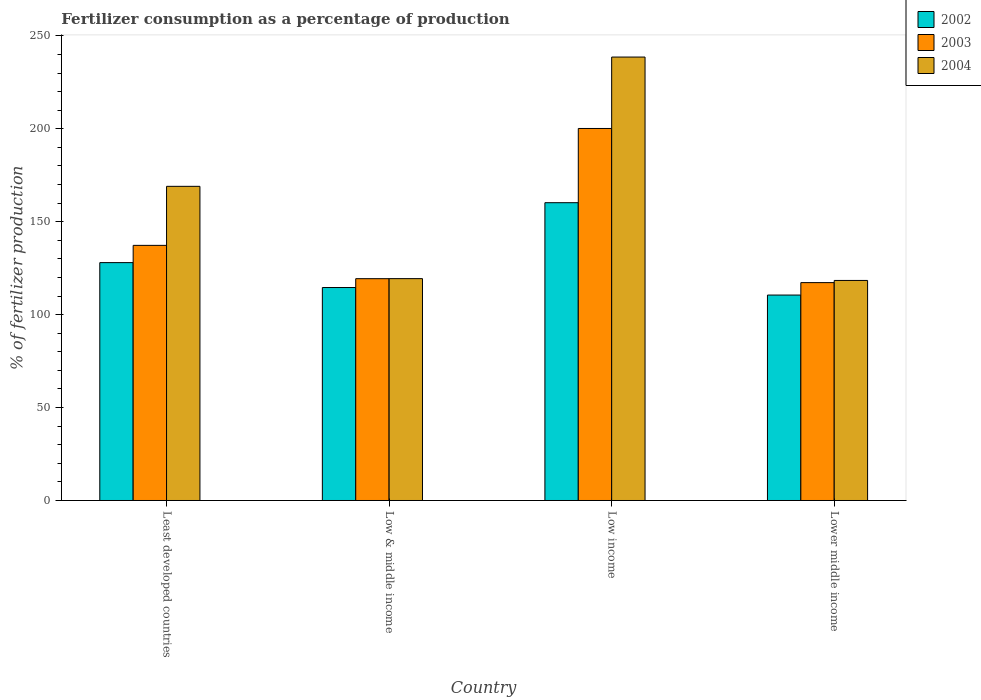How many groups of bars are there?
Provide a succinct answer. 4. How many bars are there on the 4th tick from the left?
Ensure brevity in your answer.  3. How many bars are there on the 1st tick from the right?
Give a very brief answer. 3. What is the label of the 4th group of bars from the left?
Provide a short and direct response. Lower middle income. What is the percentage of fertilizers consumed in 2002 in Least developed countries?
Your response must be concise. 128. Across all countries, what is the maximum percentage of fertilizers consumed in 2003?
Make the answer very short. 200.18. Across all countries, what is the minimum percentage of fertilizers consumed in 2002?
Offer a very short reply. 110.54. In which country was the percentage of fertilizers consumed in 2002 maximum?
Give a very brief answer. Low income. In which country was the percentage of fertilizers consumed in 2004 minimum?
Keep it short and to the point. Lower middle income. What is the total percentage of fertilizers consumed in 2004 in the graph?
Offer a very short reply. 645.43. What is the difference between the percentage of fertilizers consumed in 2003 in Low & middle income and that in Lower middle income?
Make the answer very short. 2.13. What is the difference between the percentage of fertilizers consumed in 2002 in Low income and the percentage of fertilizers consumed in 2004 in Lower middle income?
Ensure brevity in your answer.  41.84. What is the average percentage of fertilizers consumed in 2003 per country?
Make the answer very short. 143.51. What is the difference between the percentage of fertilizers consumed of/in 2004 and percentage of fertilizers consumed of/in 2002 in Low income?
Ensure brevity in your answer.  78.37. In how many countries, is the percentage of fertilizers consumed in 2002 greater than 30 %?
Make the answer very short. 4. What is the ratio of the percentage of fertilizers consumed in 2004 in Low & middle income to that in Low income?
Your response must be concise. 0.5. Is the difference between the percentage of fertilizers consumed in 2004 in Least developed countries and Low income greater than the difference between the percentage of fertilizers consumed in 2002 in Least developed countries and Low income?
Provide a succinct answer. No. What is the difference between the highest and the second highest percentage of fertilizers consumed in 2004?
Your response must be concise. -69.57. What is the difference between the highest and the lowest percentage of fertilizers consumed in 2004?
Your answer should be very brief. 120.21. What does the 2nd bar from the right in Lower middle income represents?
Keep it short and to the point. 2003. Is it the case that in every country, the sum of the percentage of fertilizers consumed in 2003 and percentage of fertilizers consumed in 2004 is greater than the percentage of fertilizers consumed in 2002?
Keep it short and to the point. Yes. Are all the bars in the graph horizontal?
Offer a terse response. No. How many countries are there in the graph?
Make the answer very short. 4. What is the difference between two consecutive major ticks on the Y-axis?
Make the answer very short. 50. Are the values on the major ticks of Y-axis written in scientific E-notation?
Keep it short and to the point. No. Does the graph contain any zero values?
Provide a short and direct response. No. Does the graph contain grids?
Give a very brief answer. No. Where does the legend appear in the graph?
Provide a succinct answer. Top right. What is the title of the graph?
Provide a succinct answer. Fertilizer consumption as a percentage of production. Does "1992" appear as one of the legend labels in the graph?
Your answer should be compact. No. What is the label or title of the X-axis?
Offer a very short reply. Country. What is the label or title of the Y-axis?
Offer a very short reply. % of fertilizer production. What is the % of fertilizer production of 2002 in Least developed countries?
Ensure brevity in your answer.  128. What is the % of fertilizer production in 2003 in Least developed countries?
Offer a terse response. 137.28. What is the % of fertilizer production of 2004 in Least developed countries?
Provide a short and direct response. 169.04. What is the % of fertilizer production of 2002 in Low & middle income?
Your answer should be compact. 114.59. What is the % of fertilizer production in 2003 in Low & middle income?
Make the answer very short. 119.36. What is the % of fertilizer production of 2004 in Low & middle income?
Your response must be concise. 119.38. What is the % of fertilizer production of 2002 in Low income?
Keep it short and to the point. 160.24. What is the % of fertilizer production of 2003 in Low income?
Your answer should be very brief. 200.18. What is the % of fertilizer production in 2004 in Low income?
Provide a succinct answer. 238.61. What is the % of fertilizer production in 2002 in Lower middle income?
Provide a succinct answer. 110.54. What is the % of fertilizer production in 2003 in Lower middle income?
Your response must be concise. 117.23. What is the % of fertilizer production of 2004 in Lower middle income?
Your answer should be very brief. 118.4. Across all countries, what is the maximum % of fertilizer production in 2002?
Your response must be concise. 160.24. Across all countries, what is the maximum % of fertilizer production of 2003?
Offer a terse response. 200.18. Across all countries, what is the maximum % of fertilizer production of 2004?
Give a very brief answer. 238.61. Across all countries, what is the minimum % of fertilizer production in 2002?
Provide a succinct answer. 110.54. Across all countries, what is the minimum % of fertilizer production of 2003?
Offer a very short reply. 117.23. Across all countries, what is the minimum % of fertilizer production of 2004?
Ensure brevity in your answer.  118.4. What is the total % of fertilizer production in 2002 in the graph?
Provide a short and direct response. 513.37. What is the total % of fertilizer production of 2003 in the graph?
Keep it short and to the point. 574.04. What is the total % of fertilizer production in 2004 in the graph?
Offer a very short reply. 645.43. What is the difference between the % of fertilizer production in 2002 in Least developed countries and that in Low & middle income?
Offer a terse response. 13.4. What is the difference between the % of fertilizer production in 2003 in Least developed countries and that in Low & middle income?
Your answer should be very brief. 17.92. What is the difference between the % of fertilizer production in 2004 in Least developed countries and that in Low & middle income?
Your answer should be compact. 49.66. What is the difference between the % of fertilizer production in 2002 in Least developed countries and that in Low income?
Keep it short and to the point. -32.24. What is the difference between the % of fertilizer production of 2003 in Least developed countries and that in Low income?
Provide a short and direct response. -62.9. What is the difference between the % of fertilizer production of 2004 in Least developed countries and that in Low income?
Provide a succinct answer. -69.57. What is the difference between the % of fertilizer production of 2002 in Least developed countries and that in Lower middle income?
Provide a succinct answer. 17.46. What is the difference between the % of fertilizer production in 2003 in Least developed countries and that in Lower middle income?
Provide a succinct answer. 20.05. What is the difference between the % of fertilizer production in 2004 in Least developed countries and that in Lower middle income?
Offer a terse response. 50.64. What is the difference between the % of fertilizer production in 2002 in Low & middle income and that in Low income?
Provide a short and direct response. -45.65. What is the difference between the % of fertilizer production in 2003 in Low & middle income and that in Low income?
Provide a short and direct response. -80.82. What is the difference between the % of fertilizer production in 2004 in Low & middle income and that in Low income?
Provide a short and direct response. -119.23. What is the difference between the % of fertilizer production of 2002 in Low & middle income and that in Lower middle income?
Provide a short and direct response. 4.06. What is the difference between the % of fertilizer production in 2003 in Low & middle income and that in Lower middle income?
Ensure brevity in your answer.  2.13. What is the difference between the % of fertilizer production of 2004 in Low & middle income and that in Lower middle income?
Give a very brief answer. 0.98. What is the difference between the % of fertilizer production of 2002 in Low income and that in Lower middle income?
Provide a short and direct response. 49.7. What is the difference between the % of fertilizer production in 2003 in Low income and that in Lower middle income?
Your response must be concise. 82.95. What is the difference between the % of fertilizer production of 2004 in Low income and that in Lower middle income?
Provide a succinct answer. 120.21. What is the difference between the % of fertilizer production of 2002 in Least developed countries and the % of fertilizer production of 2003 in Low & middle income?
Provide a short and direct response. 8.64. What is the difference between the % of fertilizer production in 2002 in Least developed countries and the % of fertilizer production in 2004 in Low & middle income?
Offer a very short reply. 8.62. What is the difference between the % of fertilizer production in 2003 in Least developed countries and the % of fertilizer production in 2004 in Low & middle income?
Keep it short and to the point. 17.9. What is the difference between the % of fertilizer production in 2002 in Least developed countries and the % of fertilizer production in 2003 in Low income?
Keep it short and to the point. -72.18. What is the difference between the % of fertilizer production in 2002 in Least developed countries and the % of fertilizer production in 2004 in Low income?
Ensure brevity in your answer.  -110.61. What is the difference between the % of fertilizer production of 2003 in Least developed countries and the % of fertilizer production of 2004 in Low income?
Offer a very short reply. -101.33. What is the difference between the % of fertilizer production in 2002 in Least developed countries and the % of fertilizer production in 2003 in Lower middle income?
Give a very brief answer. 10.77. What is the difference between the % of fertilizer production in 2002 in Least developed countries and the % of fertilizer production in 2004 in Lower middle income?
Make the answer very short. 9.6. What is the difference between the % of fertilizer production of 2003 in Least developed countries and the % of fertilizer production of 2004 in Lower middle income?
Provide a short and direct response. 18.88. What is the difference between the % of fertilizer production of 2002 in Low & middle income and the % of fertilizer production of 2003 in Low income?
Provide a succinct answer. -85.58. What is the difference between the % of fertilizer production in 2002 in Low & middle income and the % of fertilizer production in 2004 in Low income?
Your answer should be very brief. -124.02. What is the difference between the % of fertilizer production in 2003 in Low & middle income and the % of fertilizer production in 2004 in Low income?
Make the answer very short. -119.26. What is the difference between the % of fertilizer production in 2002 in Low & middle income and the % of fertilizer production in 2003 in Lower middle income?
Your answer should be compact. -2.64. What is the difference between the % of fertilizer production in 2002 in Low & middle income and the % of fertilizer production in 2004 in Lower middle income?
Keep it short and to the point. -3.81. What is the difference between the % of fertilizer production of 2003 in Low & middle income and the % of fertilizer production of 2004 in Lower middle income?
Offer a very short reply. 0.96. What is the difference between the % of fertilizer production of 2002 in Low income and the % of fertilizer production of 2003 in Lower middle income?
Provide a short and direct response. 43.01. What is the difference between the % of fertilizer production of 2002 in Low income and the % of fertilizer production of 2004 in Lower middle income?
Ensure brevity in your answer.  41.84. What is the difference between the % of fertilizer production in 2003 in Low income and the % of fertilizer production in 2004 in Lower middle income?
Provide a short and direct response. 81.78. What is the average % of fertilizer production of 2002 per country?
Offer a very short reply. 128.34. What is the average % of fertilizer production of 2003 per country?
Keep it short and to the point. 143.51. What is the average % of fertilizer production in 2004 per country?
Your answer should be compact. 161.36. What is the difference between the % of fertilizer production in 2002 and % of fertilizer production in 2003 in Least developed countries?
Offer a very short reply. -9.28. What is the difference between the % of fertilizer production in 2002 and % of fertilizer production in 2004 in Least developed countries?
Keep it short and to the point. -41.04. What is the difference between the % of fertilizer production of 2003 and % of fertilizer production of 2004 in Least developed countries?
Ensure brevity in your answer.  -31.76. What is the difference between the % of fertilizer production of 2002 and % of fertilizer production of 2003 in Low & middle income?
Offer a very short reply. -4.76. What is the difference between the % of fertilizer production of 2002 and % of fertilizer production of 2004 in Low & middle income?
Provide a succinct answer. -4.79. What is the difference between the % of fertilizer production of 2003 and % of fertilizer production of 2004 in Low & middle income?
Keep it short and to the point. -0.02. What is the difference between the % of fertilizer production of 2002 and % of fertilizer production of 2003 in Low income?
Keep it short and to the point. -39.94. What is the difference between the % of fertilizer production in 2002 and % of fertilizer production in 2004 in Low income?
Keep it short and to the point. -78.37. What is the difference between the % of fertilizer production of 2003 and % of fertilizer production of 2004 in Low income?
Provide a succinct answer. -38.43. What is the difference between the % of fertilizer production of 2002 and % of fertilizer production of 2003 in Lower middle income?
Give a very brief answer. -6.69. What is the difference between the % of fertilizer production of 2002 and % of fertilizer production of 2004 in Lower middle income?
Offer a terse response. -7.86. What is the difference between the % of fertilizer production in 2003 and % of fertilizer production in 2004 in Lower middle income?
Your answer should be very brief. -1.17. What is the ratio of the % of fertilizer production in 2002 in Least developed countries to that in Low & middle income?
Your answer should be very brief. 1.12. What is the ratio of the % of fertilizer production in 2003 in Least developed countries to that in Low & middle income?
Offer a terse response. 1.15. What is the ratio of the % of fertilizer production in 2004 in Least developed countries to that in Low & middle income?
Give a very brief answer. 1.42. What is the ratio of the % of fertilizer production of 2002 in Least developed countries to that in Low income?
Make the answer very short. 0.8. What is the ratio of the % of fertilizer production in 2003 in Least developed countries to that in Low income?
Ensure brevity in your answer.  0.69. What is the ratio of the % of fertilizer production of 2004 in Least developed countries to that in Low income?
Your answer should be very brief. 0.71. What is the ratio of the % of fertilizer production in 2002 in Least developed countries to that in Lower middle income?
Ensure brevity in your answer.  1.16. What is the ratio of the % of fertilizer production in 2003 in Least developed countries to that in Lower middle income?
Keep it short and to the point. 1.17. What is the ratio of the % of fertilizer production in 2004 in Least developed countries to that in Lower middle income?
Your answer should be compact. 1.43. What is the ratio of the % of fertilizer production in 2002 in Low & middle income to that in Low income?
Give a very brief answer. 0.72. What is the ratio of the % of fertilizer production in 2003 in Low & middle income to that in Low income?
Ensure brevity in your answer.  0.6. What is the ratio of the % of fertilizer production of 2004 in Low & middle income to that in Low income?
Give a very brief answer. 0.5. What is the ratio of the % of fertilizer production of 2002 in Low & middle income to that in Lower middle income?
Your response must be concise. 1.04. What is the ratio of the % of fertilizer production of 2003 in Low & middle income to that in Lower middle income?
Provide a short and direct response. 1.02. What is the ratio of the % of fertilizer production in 2004 in Low & middle income to that in Lower middle income?
Ensure brevity in your answer.  1.01. What is the ratio of the % of fertilizer production in 2002 in Low income to that in Lower middle income?
Your answer should be compact. 1.45. What is the ratio of the % of fertilizer production in 2003 in Low income to that in Lower middle income?
Offer a terse response. 1.71. What is the ratio of the % of fertilizer production of 2004 in Low income to that in Lower middle income?
Ensure brevity in your answer.  2.02. What is the difference between the highest and the second highest % of fertilizer production in 2002?
Offer a terse response. 32.24. What is the difference between the highest and the second highest % of fertilizer production in 2003?
Make the answer very short. 62.9. What is the difference between the highest and the second highest % of fertilizer production of 2004?
Your response must be concise. 69.57. What is the difference between the highest and the lowest % of fertilizer production in 2002?
Your answer should be compact. 49.7. What is the difference between the highest and the lowest % of fertilizer production of 2003?
Your response must be concise. 82.95. What is the difference between the highest and the lowest % of fertilizer production of 2004?
Provide a short and direct response. 120.21. 